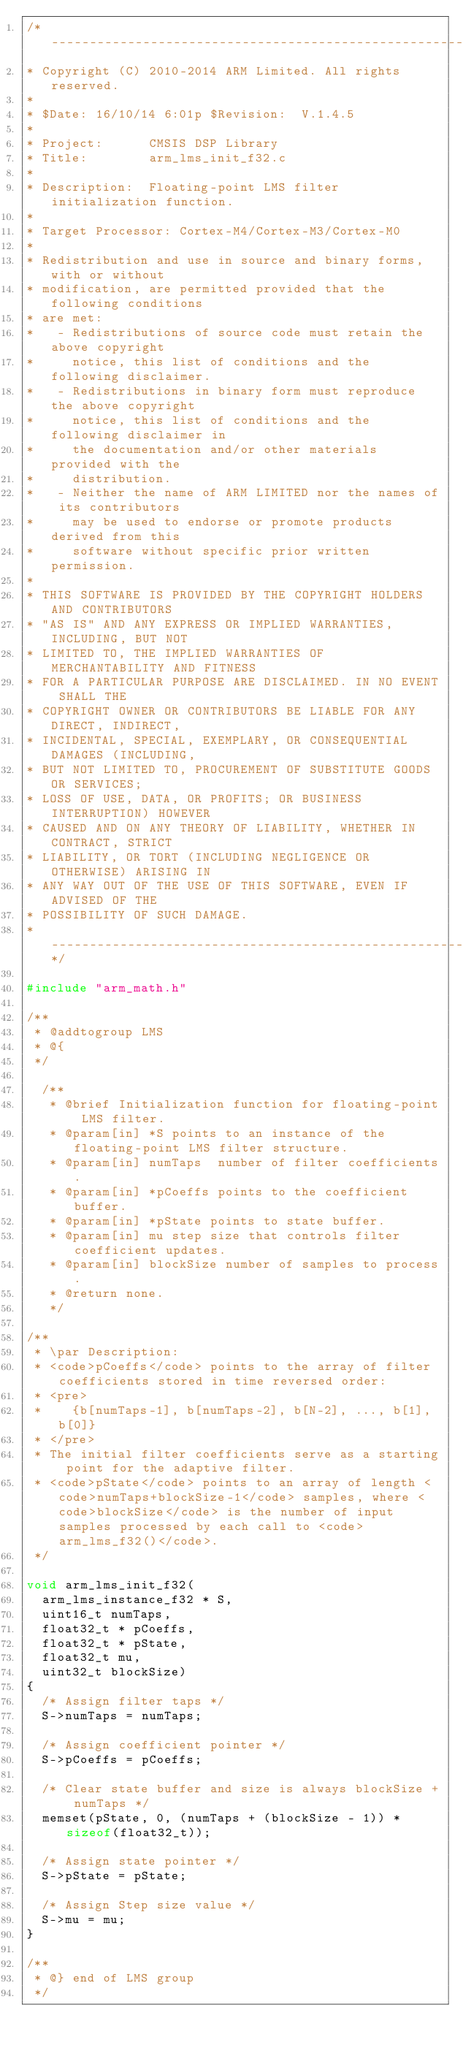Convert code to text. <code><loc_0><loc_0><loc_500><loc_500><_C_>/*-----------------------------------------------------------------------------    
* Copyright (C) 2010-2014 ARM Limited. All rights reserved.    
*    
* $Date: 16/10/14 6:01p $Revision: 	V.1.4.5
*    
* Project: 	    CMSIS DSP Library    
* Title:        arm_lms_init_f32.c    
*    
* Description:  Floating-point LMS filter initialization function.    
*    
* Target Processor: Cortex-M4/Cortex-M3/Cortex-M0
*  
* Redistribution and use in source and binary forms, with or without 
* modification, are permitted provided that the following conditions
* are met:
*   - Redistributions of source code must retain the above copyright
*     notice, this list of conditions and the following disclaimer.
*   - Redistributions in binary form must reproduce the above copyright
*     notice, this list of conditions and the following disclaimer in
*     the documentation and/or other materials provided with the 
*     distribution.
*   - Neither the name of ARM LIMITED nor the names of its contributors
*     may be used to endorse or promote products derived from this
*     software without specific prior written permission.
*
* THIS SOFTWARE IS PROVIDED BY THE COPYRIGHT HOLDERS AND CONTRIBUTORS
* "AS IS" AND ANY EXPRESS OR IMPLIED WARRANTIES, INCLUDING, BUT NOT
* LIMITED TO, THE IMPLIED WARRANTIES OF MERCHANTABILITY AND FITNESS
* FOR A PARTICULAR PURPOSE ARE DISCLAIMED. IN NO EVENT SHALL THE 
* COPYRIGHT OWNER OR CONTRIBUTORS BE LIABLE FOR ANY DIRECT, INDIRECT,
* INCIDENTAL, SPECIAL, EXEMPLARY, OR CONSEQUENTIAL DAMAGES (INCLUDING,
* BUT NOT LIMITED TO, PROCUREMENT OF SUBSTITUTE GOODS OR SERVICES;
* LOSS OF USE, DATA, OR PROFITS; OR BUSINESS INTERRUPTION) HOWEVER
* CAUSED AND ON ANY THEORY OF LIABILITY, WHETHER IN CONTRACT, STRICT
* LIABILITY, OR TORT (INCLUDING NEGLIGENCE OR OTHERWISE) ARISING IN
* ANY WAY OUT OF THE USE OF THIS SOFTWARE, EVEN IF ADVISED OF THE
* POSSIBILITY OF SUCH DAMAGE.    
* ---------------------------------------------------------------------------*/

#include "arm_math.h"

/**    
 * @addtogroup LMS    
 * @{    
 */

  /**    
   * @brief Initialization function for floating-point LMS filter.    
   * @param[in] *S points to an instance of the floating-point LMS filter structure.    
   * @param[in] numTaps  number of filter coefficients.    
   * @param[in] *pCoeffs points to the coefficient buffer.    
   * @param[in] *pState points to state buffer.    
   * @param[in] mu step size that controls filter coefficient updates.    
   * @param[in] blockSize number of samples to process.    
   * @return none.    
   */

/**    
 * \par Description:    
 * <code>pCoeffs</code> points to the array of filter coefficients stored in time reversed order:    
 * <pre>    
 *    {b[numTaps-1], b[numTaps-2], b[N-2], ..., b[1], b[0]}    
 * </pre>    
 * The initial filter coefficients serve as a starting point for the adaptive filter.    
 * <code>pState</code> points to an array of length <code>numTaps+blockSize-1</code> samples, where <code>blockSize</code> is the number of input samples processed by each call to <code>arm_lms_f32()</code>.    
 */

void arm_lms_init_f32(
  arm_lms_instance_f32 * S,
  uint16_t numTaps,
  float32_t * pCoeffs,
  float32_t * pState,
  float32_t mu,
  uint32_t blockSize)
{
  /* Assign filter taps */
  S->numTaps = numTaps;

  /* Assign coefficient pointer */
  S->pCoeffs = pCoeffs;

  /* Clear state buffer and size is always blockSize + numTaps */
  memset(pState, 0, (numTaps + (blockSize - 1)) * sizeof(float32_t));

  /* Assign state pointer */
  S->pState = pState;

  /* Assign Step size value */
  S->mu = mu;
}

/**    
 * @} end of LMS group    
 */
</code> 